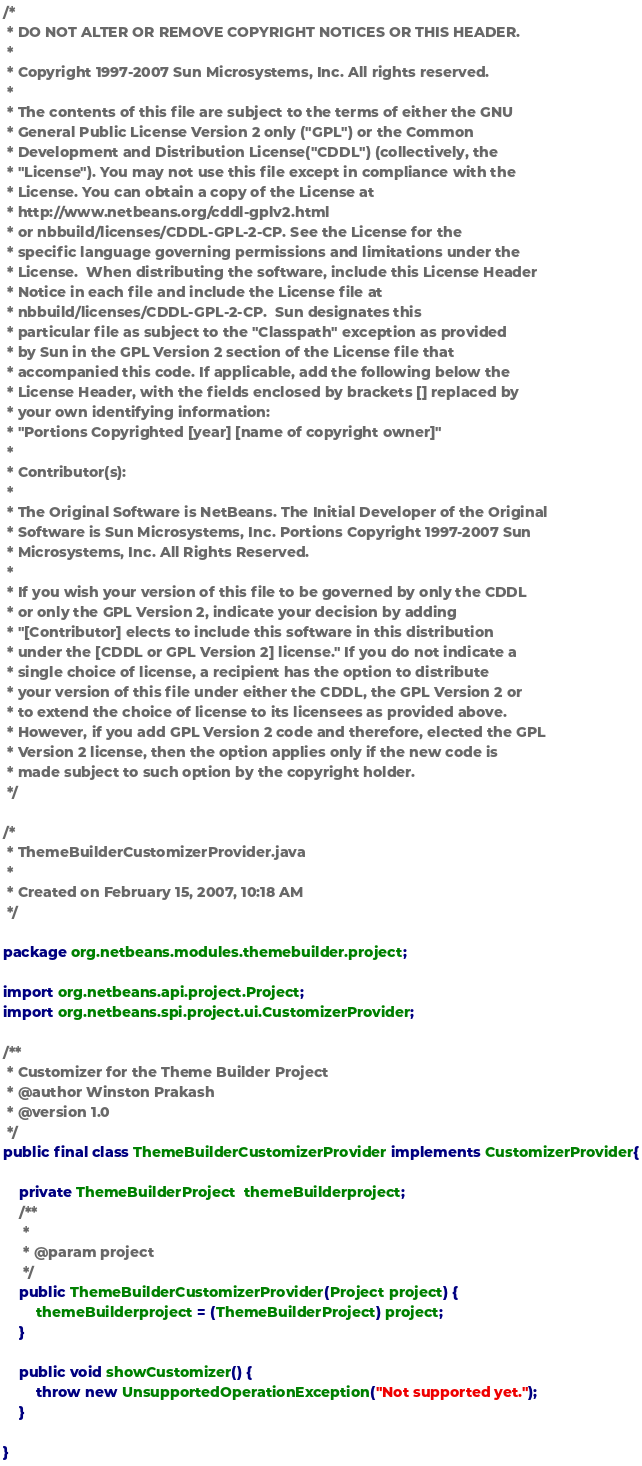<code> <loc_0><loc_0><loc_500><loc_500><_Java_>/*
 * DO NOT ALTER OR REMOVE COPYRIGHT NOTICES OR THIS HEADER.
 *
 * Copyright 1997-2007 Sun Microsystems, Inc. All rights reserved.
 *
 * The contents of this file are subject to the terms of either the GNU
 * General Public License Version 2 only ("GPL") or the Common
 * Development and Distribution License("CDDL") (collectively, the
 * "License"). You may not use this file except in compliance with the
 * License. You can obtain a copy of the License at
 * http://www.netbeans.org/cddl-gplv2.html
 * or nbbuild/licenses/CDDL-GPL-2-CP. See the License for the
 * specific language governing permissions and limitations under the
 * License.  When distributing the software, include this License Header
 * Notice in each file and include the License file at
 * nbbuild/licenses/CDDL-GPL-2-CP.  Sun designates this
 * particular file as subject to the "Classpath" exception as provided
 * by Sun in the GPL Version 2 section of the License file that
 * accompanied this code. If applicable, add the following below the
 * License Header, with the fields enclosed by brackets [] replaced by
 * your own identifying information:
 * "Portions Copyrighted [year] [name of copyright owner]"
 *
 * Contributor(s):
 *
 * The Original Software is NetBeans. The Initial Developer of the Original
 * Software is Sun Microsystems, Inc. Portions Copyright 1997-2007 Sun
 * Microsystems, Inc. All Rights Reserved.
 *
 * If you wish your version of this file to be governed by only the CDDL
 * or only the GPL Version 2, indicate your decision by adding
 * "[Contributor] elects to include this software in this distribution
 * under the [CDDL or GPL Version 2] license." If you do not indicate a
 * single choice of license, a recipient has the option to distribute
 * your version of this file under either the CDDL, the GPL Version 2 or
 * to extend the choice of license to its licensees as provided above.
 * However, if you add GPL Version 2 code and therefore, elected the GPL
 * Version 2 license, then the option applies only if the new code is
 * made subject to such option by the copyright holder.
 */

/*
 * ThemeBuilderCustomizerProvider.java
 *
 * Created on February 15, 2007, 10:18 AM
 */

package org.netbeans.modules.themebuilder.project;

import org.netbeans.api.project.Project;
import org.netbeans.spi.project.ui.CustomizerProvider;

/**
 * Customizer for the Theme Builder Project
 * @author Winston Prakash
 * @version 1.0
 */
public final class ThemeBuilderCustomizerProvider implements CustomizerProvider{
    
    private ThemeBuilderProject  themeBuilderproject;
    /**
     * 
     * @param project 
     */
    public ThemeBuilderCustomizerProvider(Project project) {
        themeBuilderproject = (ThemeBuilderProject) project;
    }
    
    public void showCustomizer() {
        throw new UnsupportedOperationException("Not supported yet.");
    }

}
</code> 